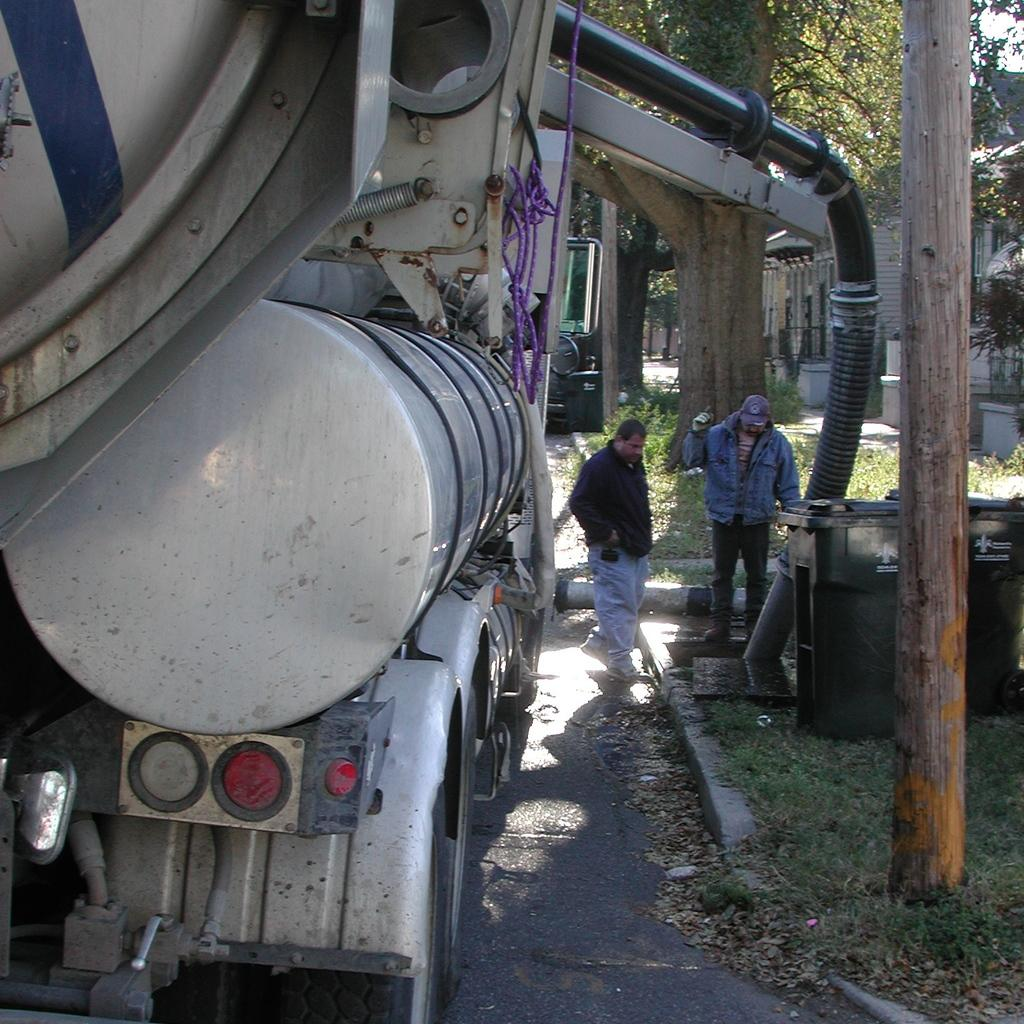How many people are in the image? There are two people standing in the image. What can be seen in the image besides the people? There are dustbins, trees, dry leaves, grass on the ground, a house, a vehicle, and other objects in the image. What color are the eyes of the person on the left in the image? There are no visible eyes in the image, as the people are not shown in close-up or with their faces visible. 